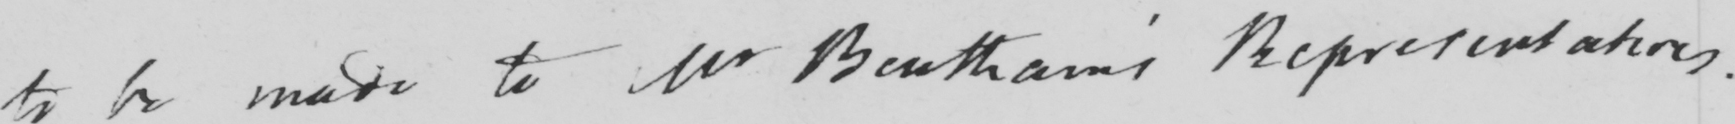What is written in this line of handwriting? to be made to Mr Bentham ' s Representatives . 